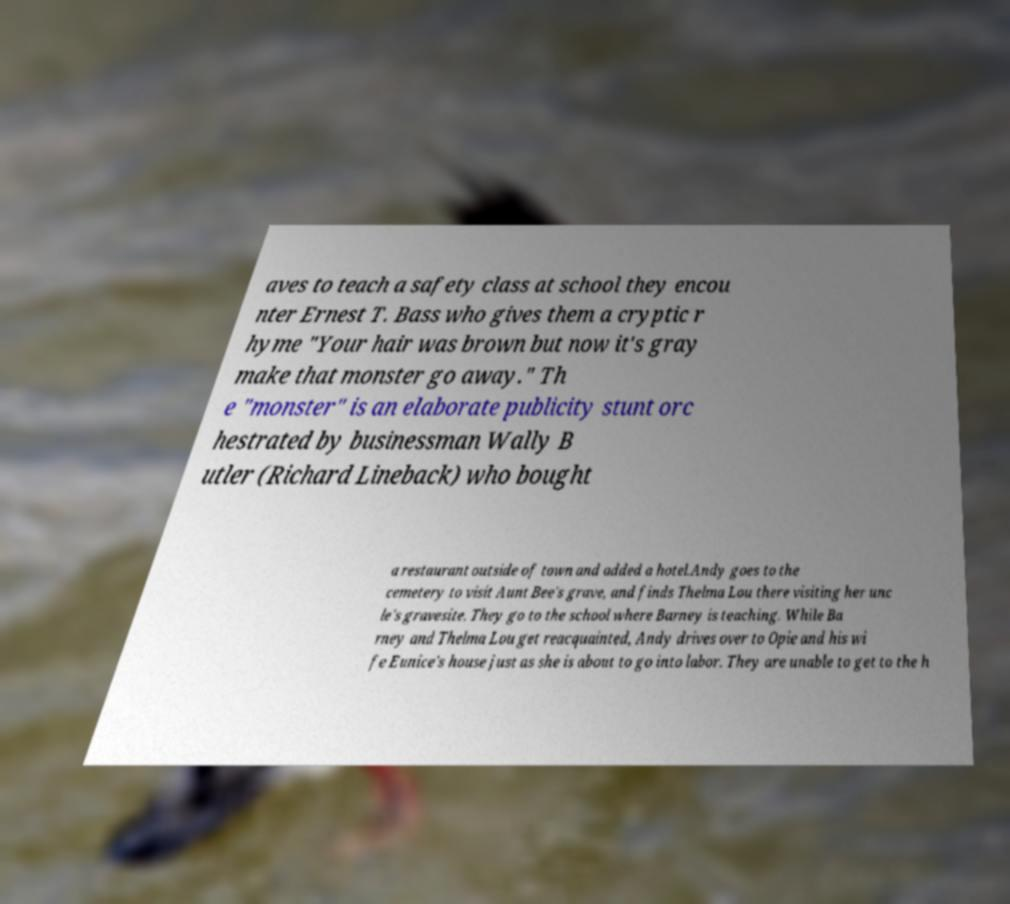I need the written content from this picture converted into text. Can you do that? aves to teach a safety class at school they encou nter Ernest T. Bass who gives them a cryptic r hyme "Your hair was brown but now it's gray make that monster go away." Th e "monster" is an elaborate publicity stunt orc hestrated by businessman Wally B utler (Richard Lineback) who bought a restaurant outside of town and added a hotel.Andy goes to the cemetery to visit Aunt Bee's grave, and finds Thelma Lou there visiting her unc le's gravesite. They go to the school where Barney is teaching. While Ba rney and Thelma Lou get reacquainted, Andy drives over to Opie and his wi fe Eunice's house just as she is about to go into labor. They are unable to get to the h 